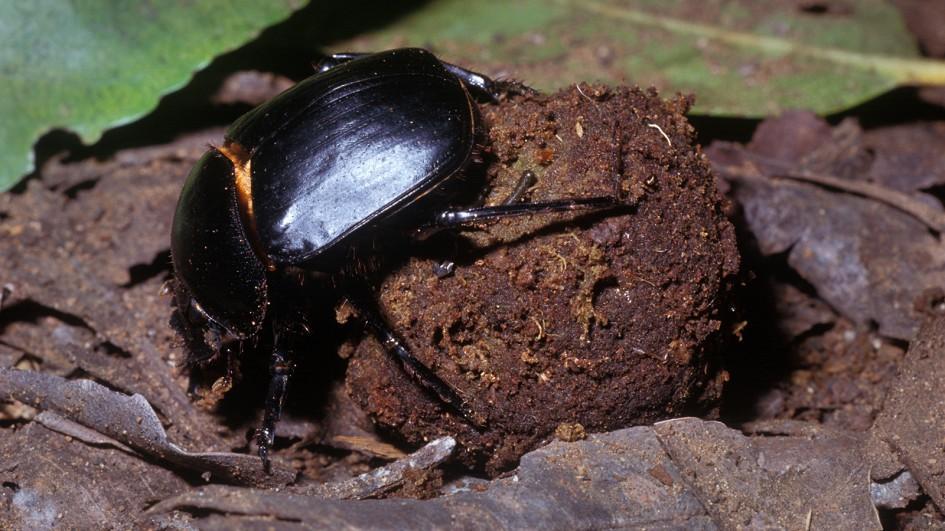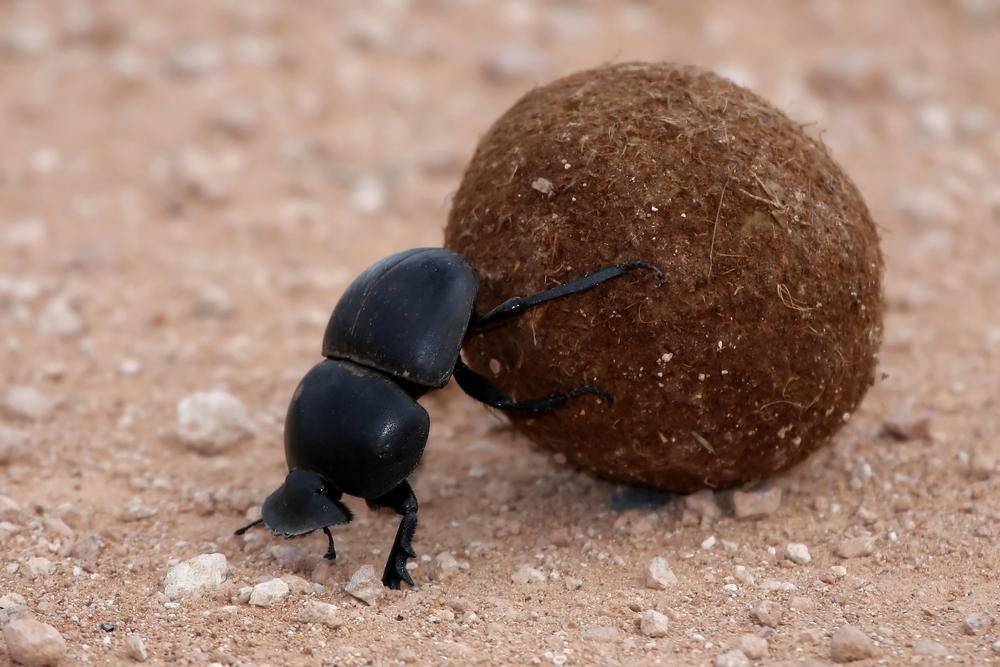The first image is the image on the left, the second image is the image on the right. Given the left and right images, does the statement "An image shows a beetle standing directly on top of a dung ball, with its body horizontal." hold true? Answer yes or no. No. The first image is the image on the left, the second image is the image on the right. Analyze the images presented: Is the assertion "There is a beetle that that's at the very top of a dungball." valid? Answer yes or no. No. 